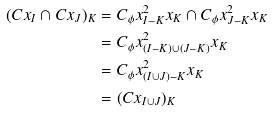<formula> <loc_0><loc_0><loc_500><loc_500>( C x _ { I } \cap C x _ { J } ) _ { K } & = C _ { \phi } x ^ { 2 } _ { I - K } x _ { K } \cap C _ { \phi } x ^ { 2 } _ { J - K } x _ { K } \\ & = C _ { \phi } x ^ { 2 } _ { ( I - K ) \cup ( J - K ) } x _ { K } \\ & = C _ { \phi } x ^ { 2 } _ { ( I \cup J ) - K } x _ { K } \\ & = ( C x _ { I \cup J } ) _ { K }</formula> 